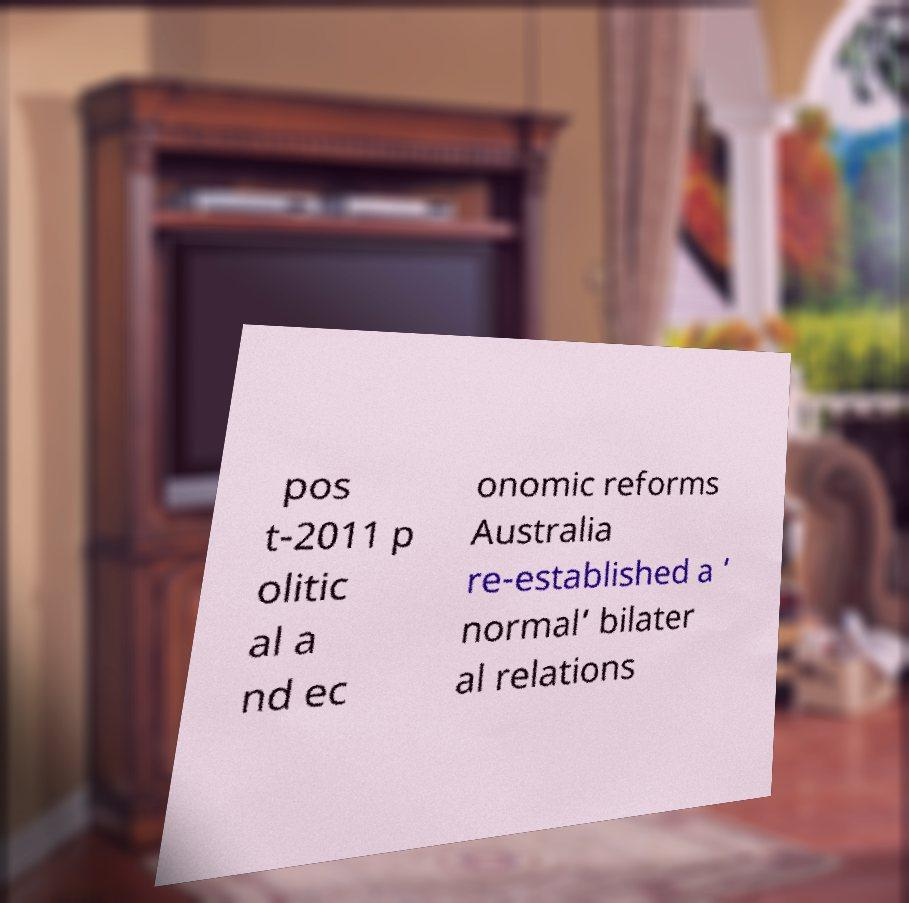Please read and relay the text visible in this image. What does it say? pos t-2011 p olitic al a nd ec onomic reforms Australia re-established a ‘ normal’ bilater al relations 